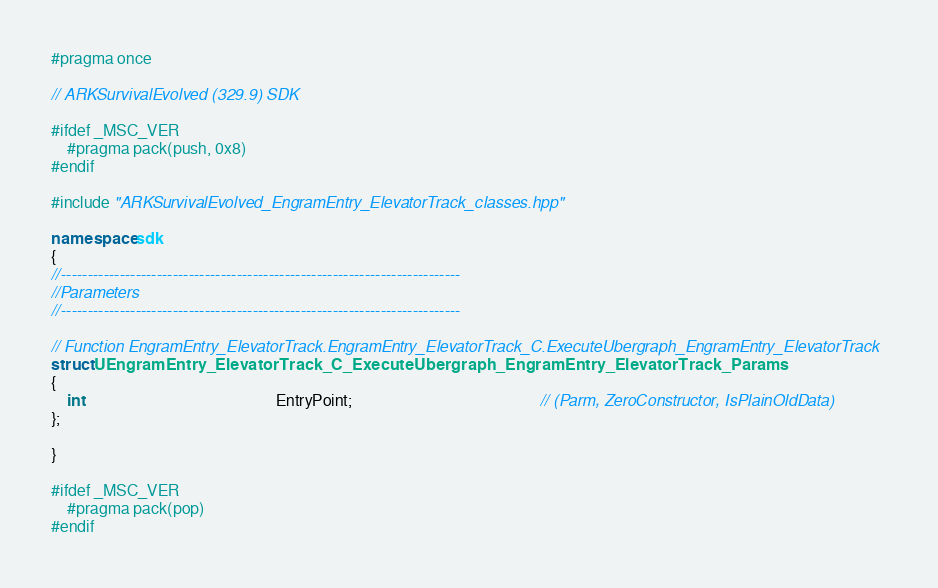<code> <loc_0><loc_0><loc_500><loc_500><_C++_>#pragma once

// ARKSurvivalEvolved (329.9) SDK

#ifdef _MSC_VER
	#pragma pack(push, 0x8)
#endif

#include "ARKSurvivalEvolved_EngramEntry_ElevatorTrack_classes.hpp"

namespace sdk
{
//---------------------------------------------------------------------------
//Parameters
//---------------------------------------------------------------------------

// Function EngramEntry_ElevatorTrack.EngramEntry_ElevatorTrack_C.ExecuteUbergraph_EngramEntry_ElevatorTrack
struct UEngramEntry_ElevatorTrack_C_ExecuteUbergraph_EngramEntry_ElevatorTrack_Params
{
	int                                                EntryPoint;                                               // (Parm, ZeroConstructor, IsPlainOldData)
};

}

#ifdef _MSC_VER
	#pragma pack(pop)
#endif
</code> 